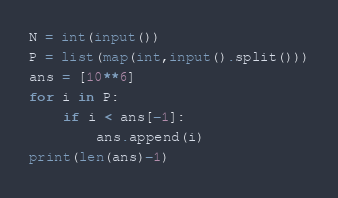Convert code to text. <code><loc_0><loc_0><loc_500><loc_500><_Python_>N = int(input())
P = list(map(int,input().split()))
ans = [10**6]
for i in P:
    if i < ans[-1]:
        ans.append(i)
print(len(ans)-1)</code> 